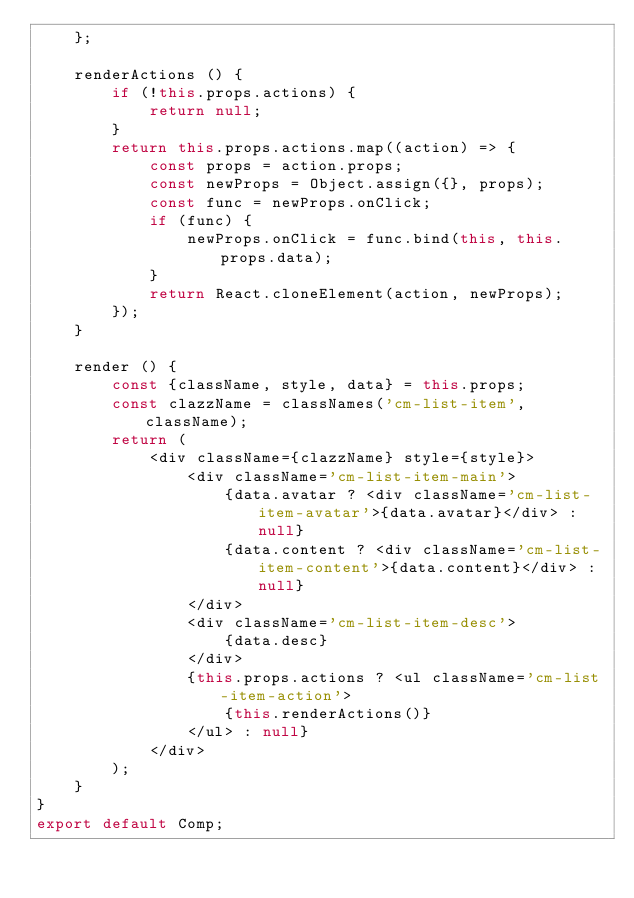Convert code to text. <code><loc_0><loc_0><loc_500><loc_500><_JavaScript_>    };

    renderActions () {
        if (!this.props.actions) {
            return null;
        }
        return this.props.actions.map((action) => {
            const props = action.props;
            const newProps = Object.assign({}, props);
            const func = newProps.onClick;
            if (func) {
                newProps.onClick = func.bind(this, this.props.data);
            }
            return React.cloneElement(action, newProps);
        });
    }

    render () {
        const {className, style, data} = this.props;
        const clazzName = classNames('cm-list-item', className);
        return (
            <div className={clazzName} style={style}>
                <div className='cm-list-item-main'>
                    {data.avatar ? <div className='cm-list-item-avatar'>{data.avatar}</div> : null}
                    {data.content ? <div className='cm-list-item-content'>{data.content}</div> : null}
                </div>
                <div className='cm-list-item-desc'>
                    {data.desc}
                </div>
                {this.props.actions ? <ul className='cm-list-item-action'>
                    {this.renderActions()}
                </ul> : null}
            </div>
        );
    }
}
export default Comp;
</code> 